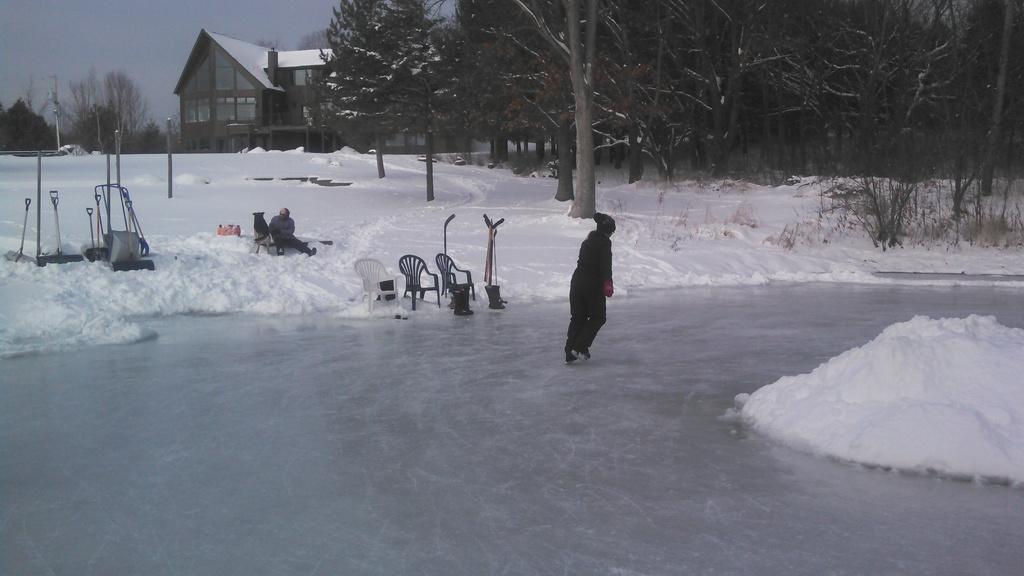Can you describe this image briefly? In this image we can see a person skating on the ice. We can also see some chairs, sticks, trees, bark of a tree, house with a roof, sky, pole and a person sitting on the ice. 